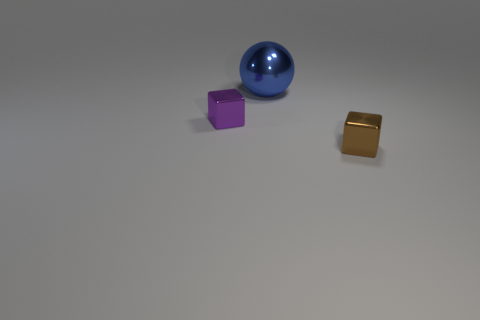How many tiny yellow cylinders have the same material as the small purple object?
Provide a succinct answer. 0. There is another thing that is the same size as the purple shiny object; what is its shape?
Ensure brevity in your answer.  Cube. There is a tiny brown shiny object; are there any small things in front of it?
Your answer should be compact. No. Are there any big purple metal things of the same shape as the blue thing?
Make the answer very short. No. Is the shape of the metal thing to the left of the large shiny thing the same as the thing in front of the purple metal block?
Ensure brevity in your answer.  Yes. Are there any red metallic spheres that have the same size as the brown thing?
Keep it short and to the point. No. Are there an equal number of tiny blocks that are in front of the small purple block and blue shiny things to the left of the brown object?
Your answer should be very brief. Yes. Do the small object left of the small brown shiny object and the small object on the right side of the big metal object have the same material?
Provide a short and direct response. Yes. What material is the small purple object?
Ensure brevity in your answer.  Metal. How many other objects are the same color as the metal sphere?
Provide a succinct answer. 0. 